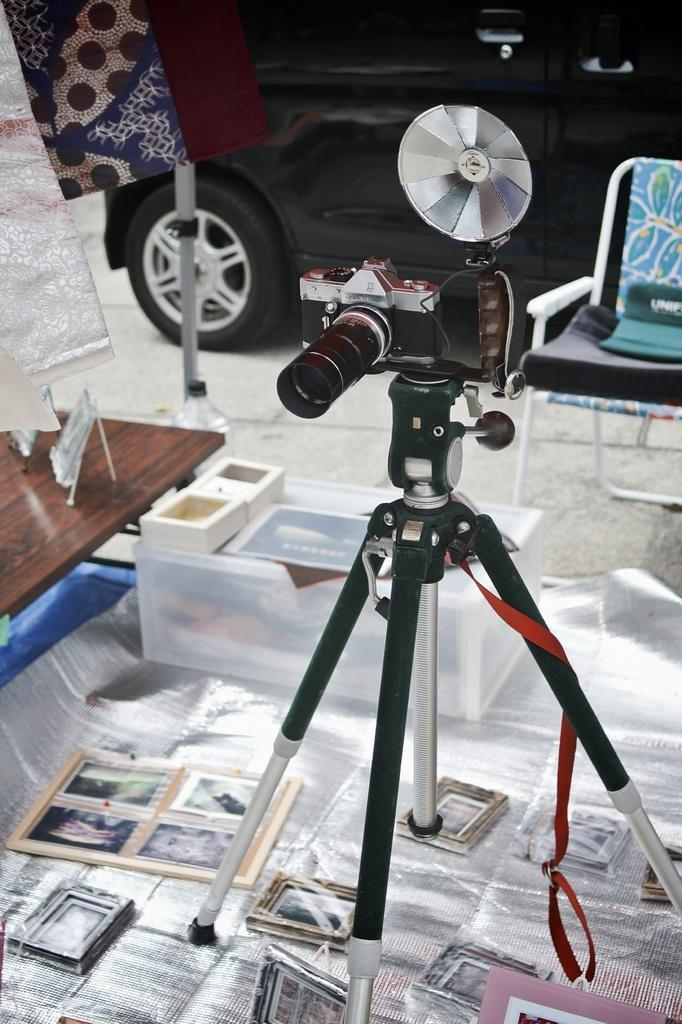What is the main subject of the image? The main subject of the image is a camera. What is supporting the camera in the image? There is a camera stand in the image that supports the camera. What can be seen in the pictures in the image? The content of the pictures is not specified, but they are present in the image. What is the container used for in the image? The purpose of the container in the image is not specified. Where are the camera and camera stand located in the image? They are on a table in the image. What type of vehicle is in the image? The type of vehicle in the image is not specified. What is the chair used for in the image? The chair is likely used for sitting, but its specific purpose is not mentioned. Can you describe the objects in the image? The objects in the image are not specified, but they are present. How far away is the railway from the camera in the image? There is no railway present in the image, so it cannot be determined how far away it is from the camera. 